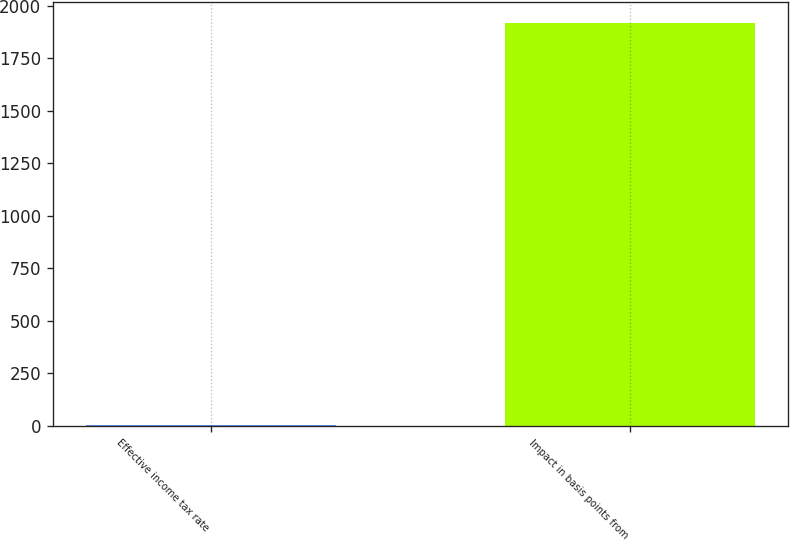Convert chart to OTSL. <chart><loc_0><loc_0><loc_500><loc_500><bar_chart><fcel>Effective income tax rate<fcel>Impact in basis points from<nl><fcel>4.8<fcel>1920<nl></chart> 